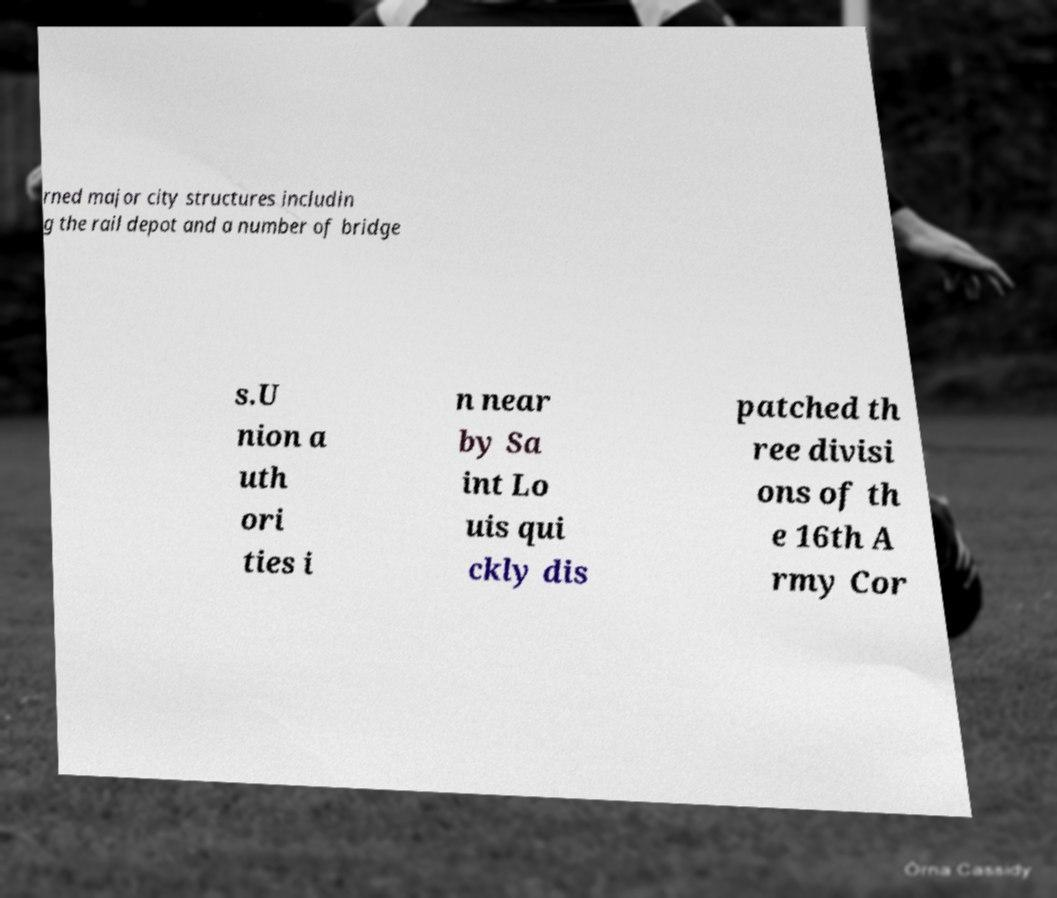Could you extract and type out the text from this image? rned major city structures includin g the rail depot and a number of bridge s.U nion a uth ori ties i n near by Sa int Lo uis qui ckly dis patched th ree divisi ons of th e 16th A rmy Cor 